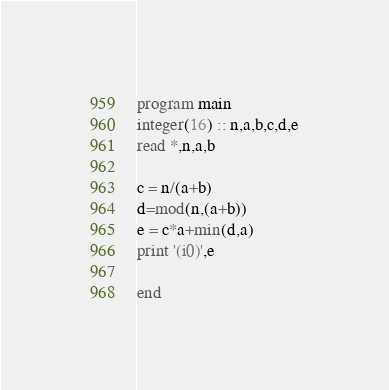<code> <loc_0><loc_0><loc_500><loc_500><_FORTRAN_>program main
integer(16) :: n,a,b,c,d,e
read *,n,a,b

c = n/(a+b)
d=mod(n,(a+b))
e = c*a+min(d,a)
print '(i0)',e

end</code> 